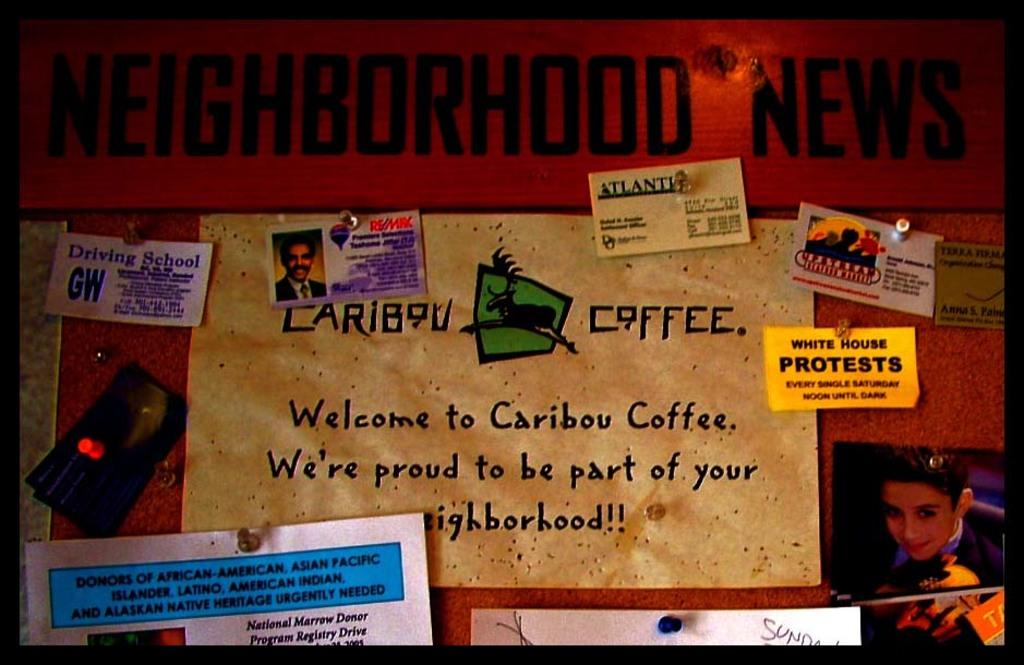What type of visual material is the image? The image is a poster. What can be found on the poster? There are many things pasted on the poster. Where is the photo of a person located on the poster? The photo of a person is on the right side of the poster. What else is present on the poster besides the photo? There is text written on the poster. What type of tools does the carpenter use in the image? There is no carpenter present in the image, so it is not possible to determine what tools they might use. What sense is being stimulated by the image? The image is visual, so it primarily stimulates the sense of sight. 